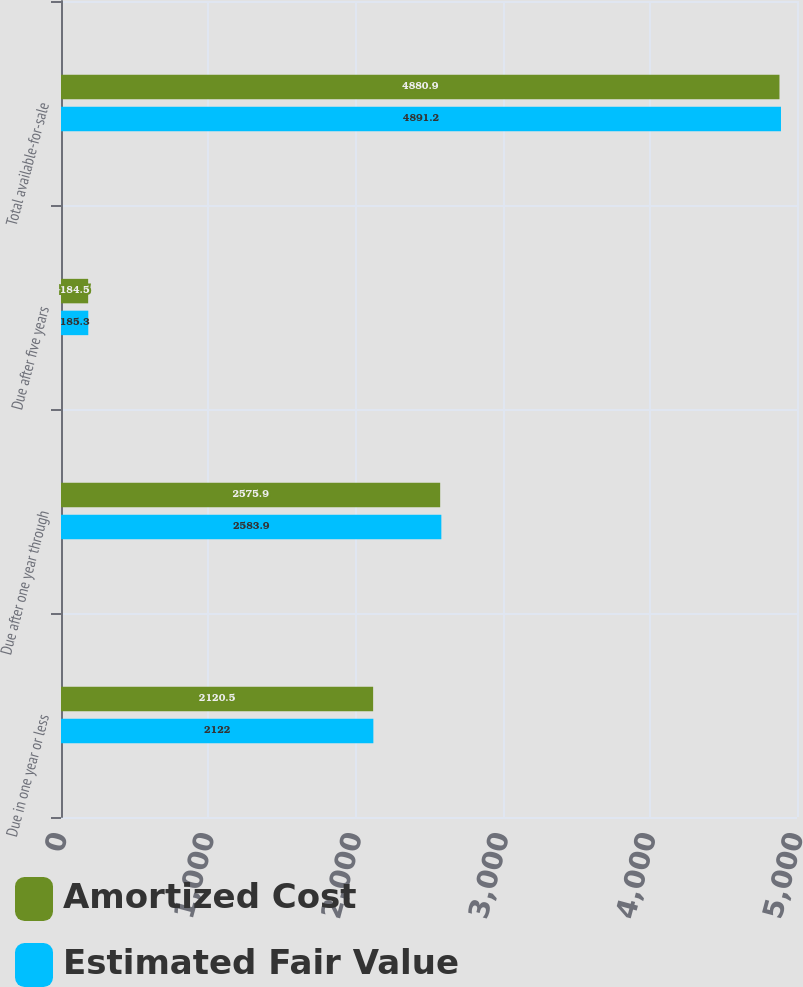Convert chart to OTSL. <chart><loc_0><loc_0><loc_500><loc_500><stacked_bar_chart><ecel><fcel>Due in one year or less<fcel>Due after one year through<fcel>Due after five years<fcel>Total available-for-sale<nl><fcel>Amortized Cost<fcel>2120.5<fcel>2575.9<fcel>184.5<fcel>4880.9<nl><fcel>Estimated Fair Value<fcel>2122<fcel>2583.9<fcel>185.3<fcel>4891.2<nl></chart> 